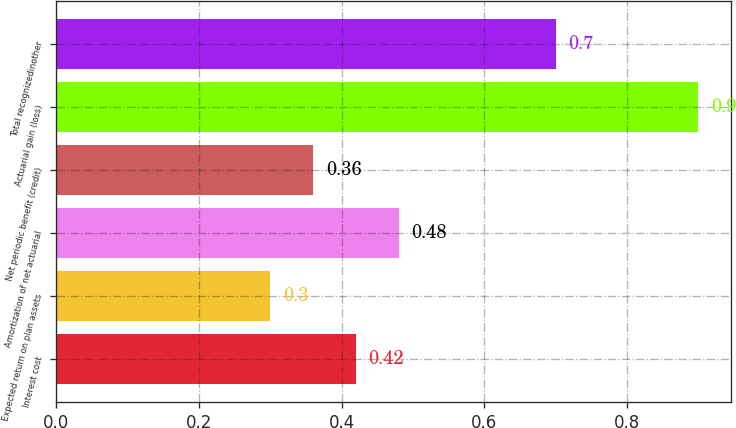Convert chart. <chart><loc_0><loc_0><loc_500><loc_500><bar_chart><fcel>Interest cost<fcel>Expected return on plan assets<fcel>Amortization of net actuarial<fcel>Net periodic benefit (credit)<fcel>Actuarial gain (loss)<fcel>Total recognizedinother<nl><fcel>0.42<fcel>0.3<fcel>0.48<fcel>0.36<fcel>0.9<fcel>0.7<nl></chart> 